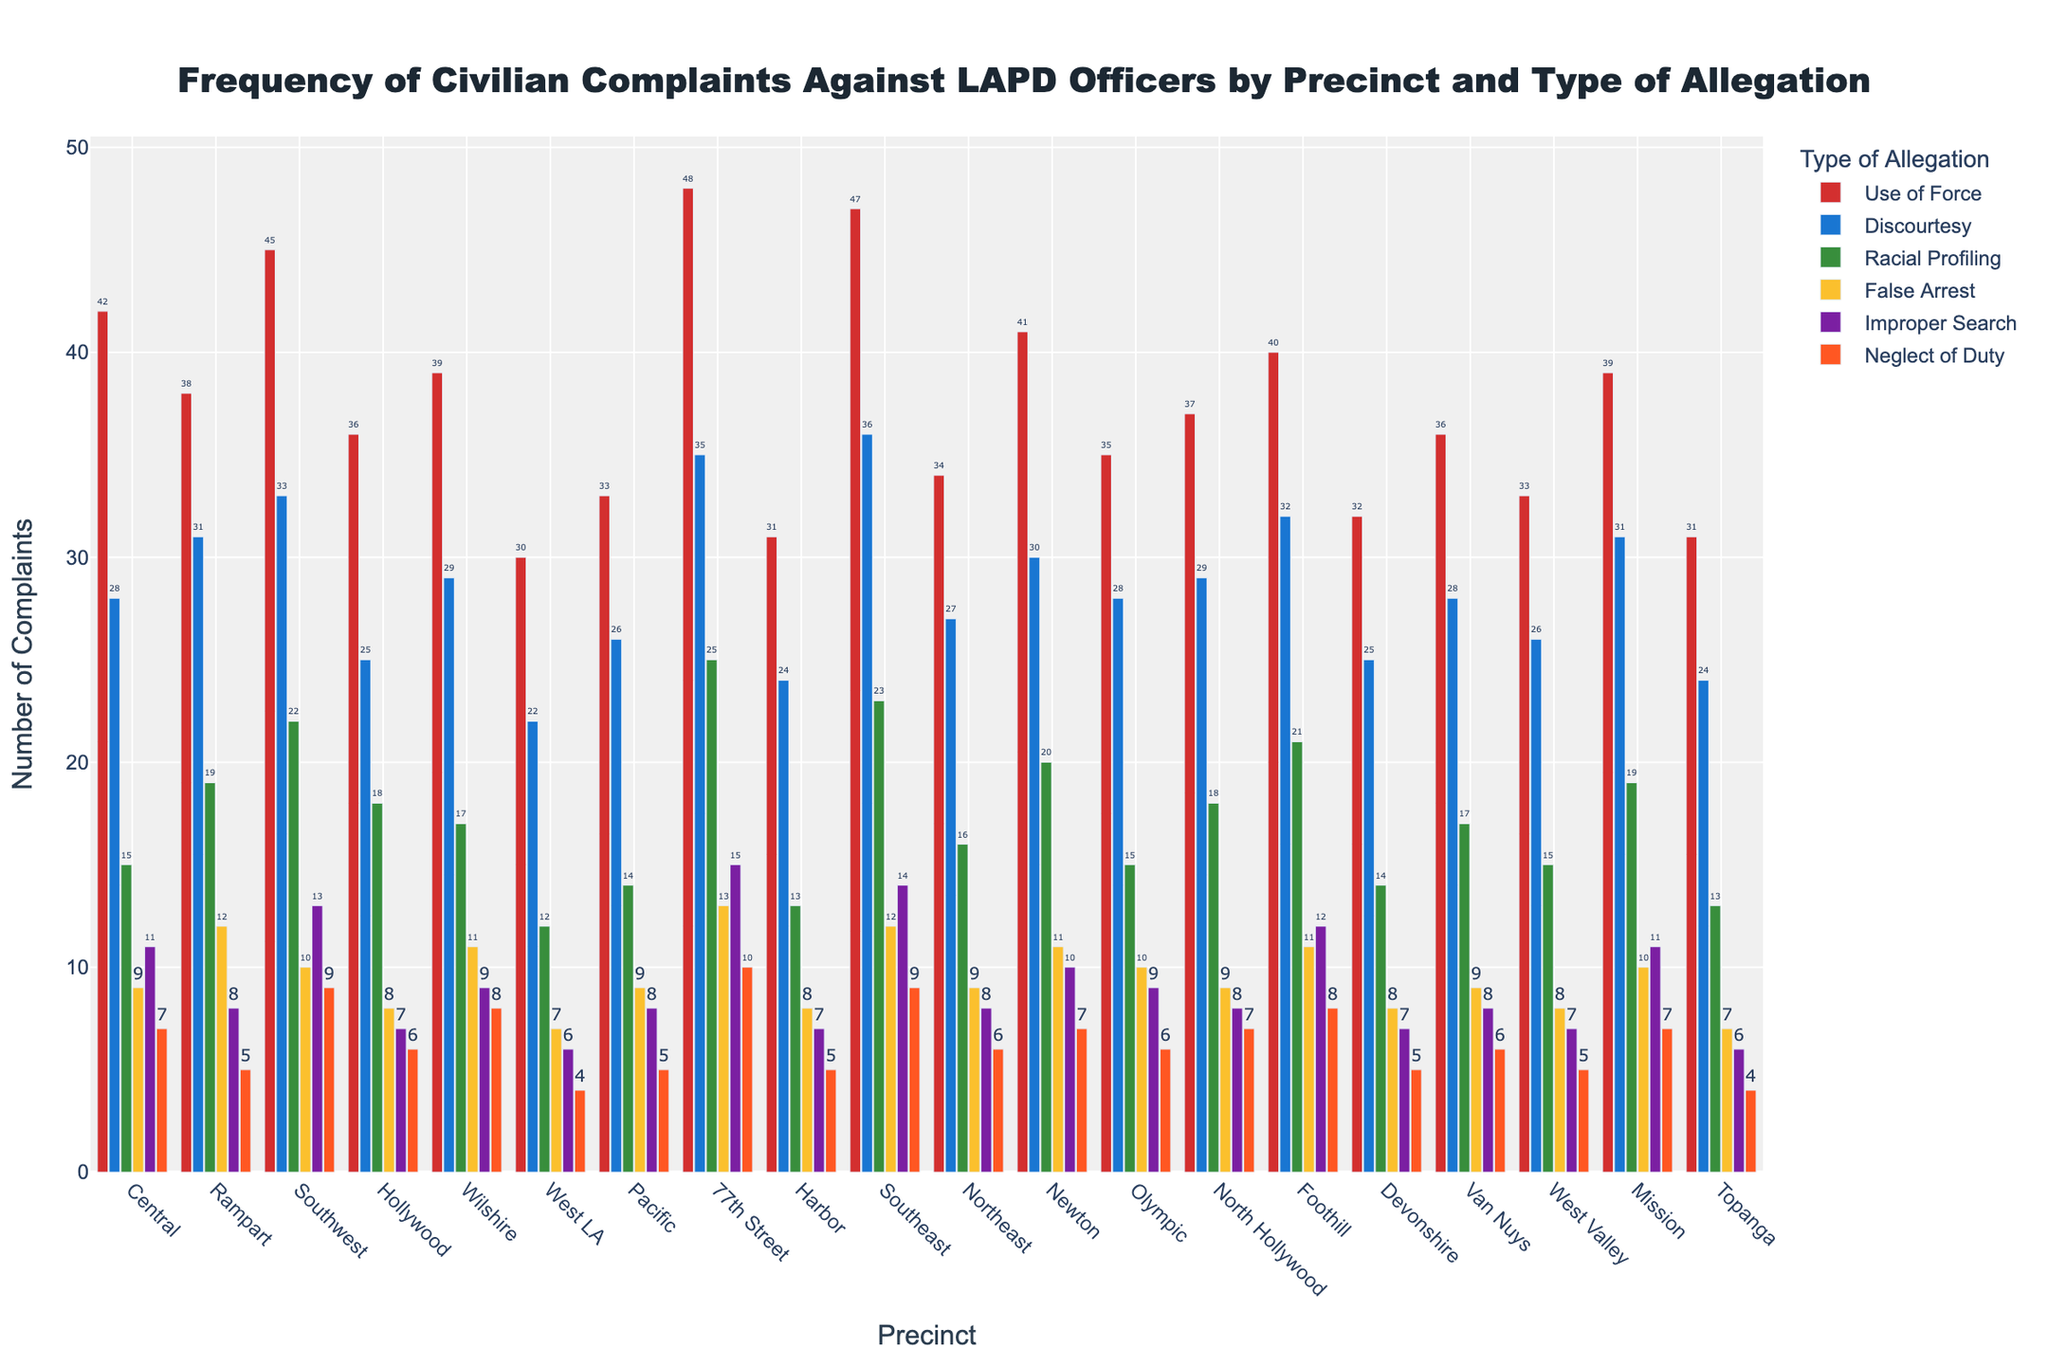what precinct has the most complaints for "Use of Force"? From the graph, we look for the precinct bar with the highest value for "Use of Force". The tallest bar for "Use of Force" is in 77th Street precinct.
Answer: 77th Street How many total complaints are there for the Central precinct? We sum the number of complaints for all types of allegations in the Central precinct: 42 (Use of Force) + 28 (Discourtesy) + 15 (Racial Profiling) + 9 (False Arrest) + 11 (Improper Search) + 7 (Neglect of Duty). The total is 112.
Answer: 112 Which precinct has more complaints for "Discourtesy": Rampart or Wilshire? From the chart, we look at the height of the bars for "Discourtesy" in both Rampart and Wilshire precincts. Rampart has 31 complaints, and Wilshire has 29 complaints for "Discourtesy". Rampart has more.
Answer: Rampart What is the average number of "False Arrest" complaints across all precincts? We need to sum up all "False Arrest" complaints: 9+12+10+8+11+7+9+13+8+12+9+11+10+9+11+8+9+8+10+7. The total is 192. Then we divide by the number of precincts (20): 192 / 20 = 9.6.
Answer: 9.6 What color represents "Racial Profiling" complaints in the chart? By looking at the legend, we can see that "Racial Profiling" complaints are represented by the green bars.
Answer: green Among "Improper Search" complaints, which precinct has the smallest number and what is that number? We examine the heights of all bars for "Improper Search" and identify the smallest one, which belongs to West LA with 6 complaints.
Answer: West LA, 6 Is the number of "Neglect of Duty" complaints in Southeast precinct greater than or equal to those in Newton precinct? From the graph, "Neglect of Duty" complaints in Southeast are 9, and those in Newton are 7. Since 9 is greater than 7, the answer is yes.
Answer: Yes What's the difference between the highest and the lowest number of "Use of Force" complaints among all precincts? The highest number of "Use of Force" complaints is 48 (77th Street), and the lowest is 30 (West LA). The difference is 48 - 30 = 18.
Answer: 18 Which precinct has the highest total complaints for "Racial Profiling" and "False Arrest" combined? For each precinct, we sum the "Racial Profiling" and "False Arrest" complaints and identify the highest:
Central: 15+9=24
Rampart: 19+12=31
Southwest: 22+10=32
Hollywood: 18+8=26
Wilshire: 17+11=28
West LA: 12+7=19
Pacific: 14+9=23
77th Street: 25+13=38
Harbor: 13+8=21
Southeast: 23+12=35
Northeast: 16+9=25
Newton: 20+11=31
Olympic: 15+10=25
North Hollywood: 18+9=27
Foothill: 21+11=32
Devonshire: 14+8=22
Van Nuys: 17+9=26
West Valley: 15+8=23
Mission: 19+10=29
Topanga: 13+7=20
77th Street precinct has the highest combined number with 38 complaints.
Answer: 77th Street In which precinct are the "Use of Force" complaints equal to the "Discourtesy" complaints? By examining the bars, we find that "Use of Force" and "Discourtesy" complaints are equal in the Hollywood precinct, both having 25 complaints.
Answer: Hollywood 